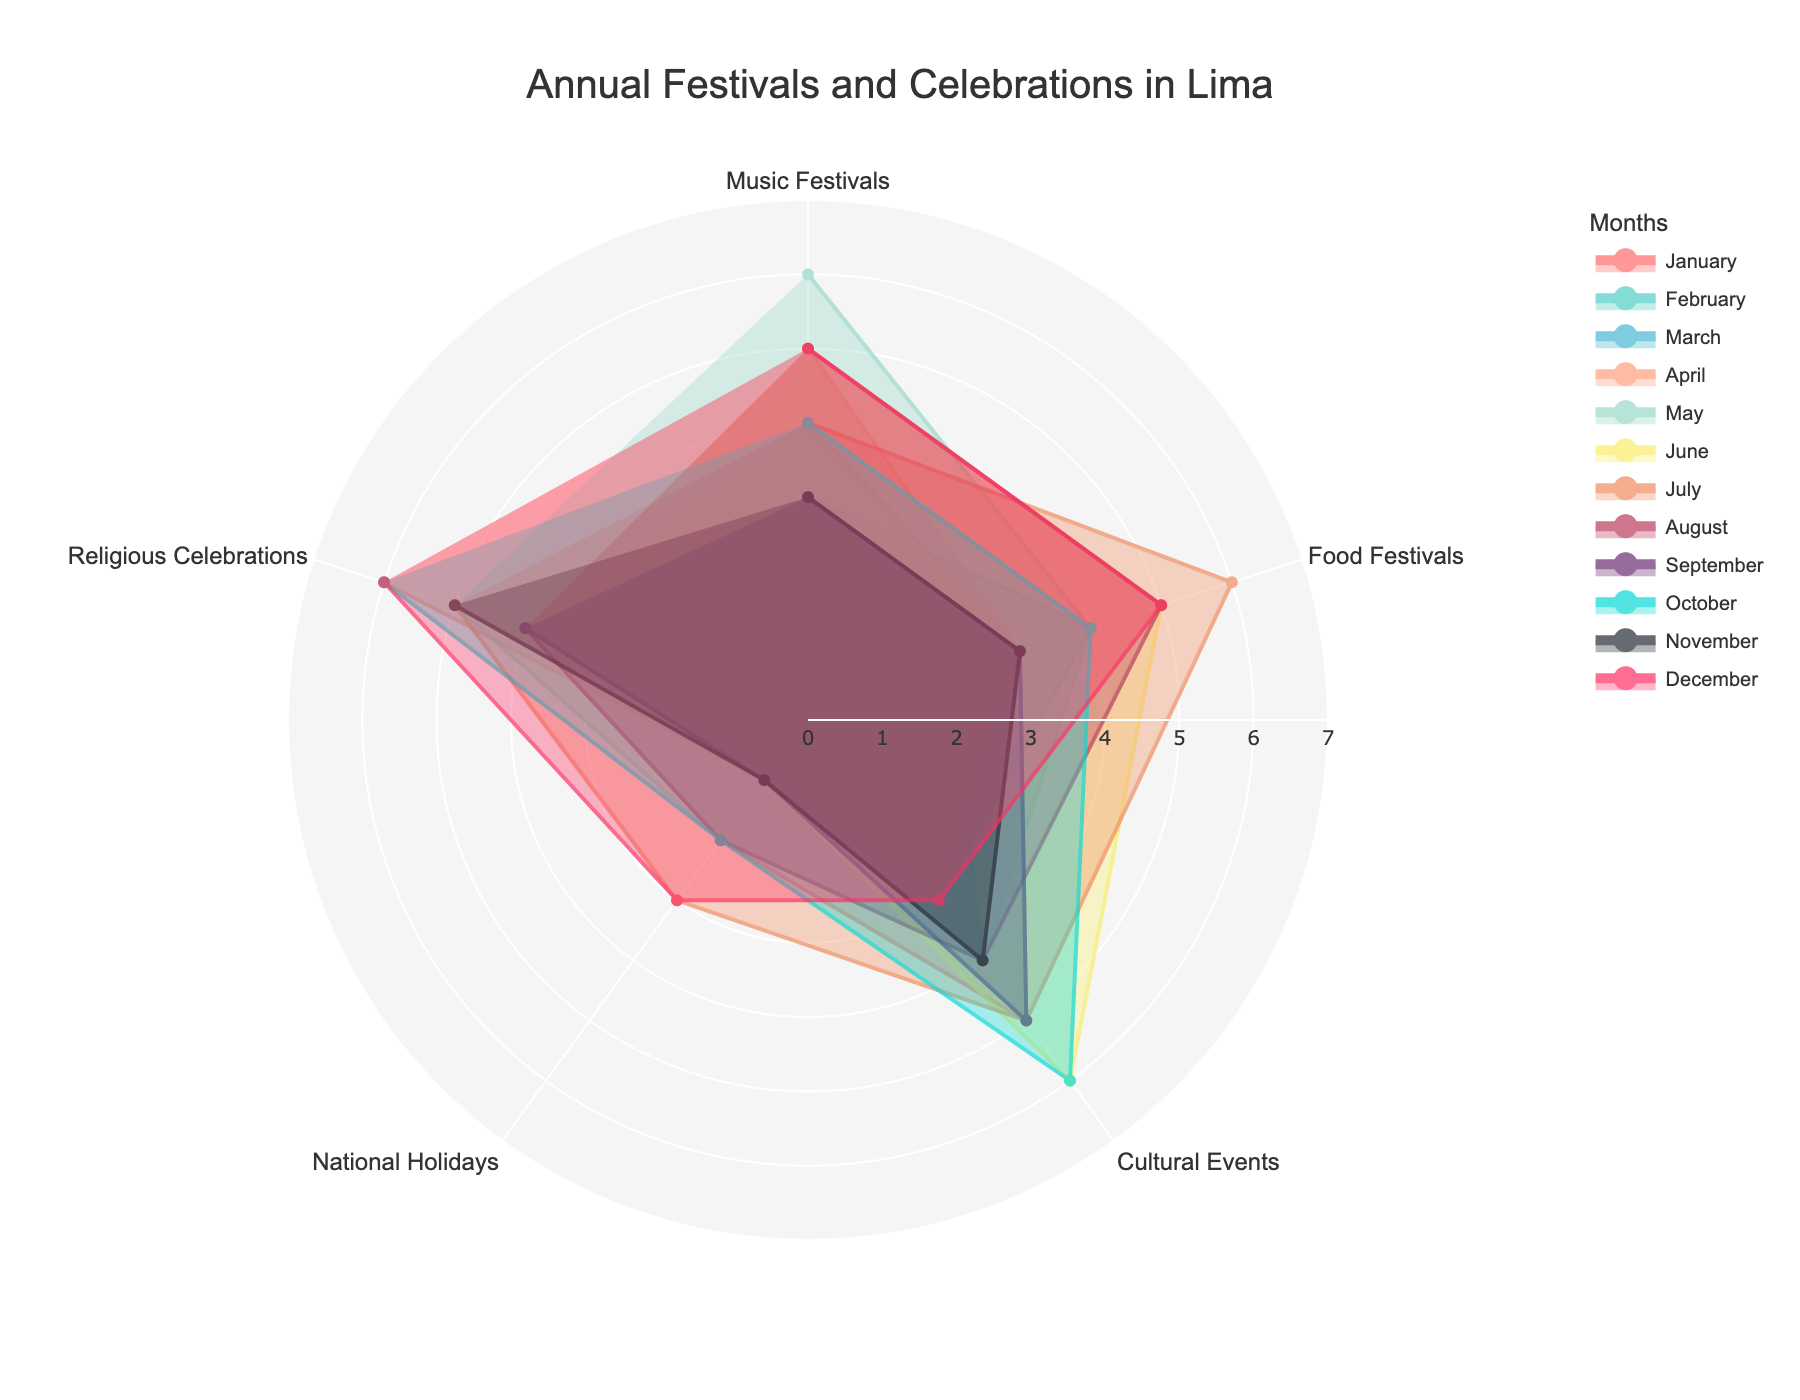What's the title of the figure? The title of the figure is located usually at the top and it gives an overall description of what the radar chart represents. The title helps in understanding the main subject of the chart.
Answer: Annual Festivals and Celebrations in Lima Which month has the highest number of Food Festivals? By examining the radar chart segments specific to Food Festivals, identify the month where the segment extends the furthest. This indicates the highest value.
Answer: July What is the average number of Religious Celebrations from January to December? Sum the values for Religious Celebrations across all months and divide by the number of months (12). (4 + 4 + 5 + 6 + 5 + 4 + 5 + 4 + 4 + 6 + 5 + 6) / 12 = 58 / 12
Answer: 4.83 During which month are Cultural Events most celebrated? Look at the specific segments for Cultural Events and find the month where this segment reaches its maximum value.
Answer: October Which has more National Holidays, April or December? Compare the segments for National Holidays in April and December. Observe which segment extends further on the radar chart.
Answer: December In which month are Music Festivals and Food Festivals equally celebrated? Compare the values for both categories across all months and find where the values match.
Answer: February Find the month with the most total celebrations (sum of all categories). Sum the values of all categories for each month and identify the month with the highest total. For example, for June: 5(Music Festivals) + 5(Food Festivals) + 6(Cultural Events) + 1(National Holidays) + 4(Religious Celebrations) = 21. Calculate for all months and compare.
Answer: June Which month has the most diverse range of festivals (highest total minus lowest total)? Determine the range of festivals by subtracting the minimum value from the maximum value for each month. Identify the month with the largest range difference.
Answer: April (6 - 1 = 5) Is there a month where there are no National Holidays? Check the values for National Holidays in each month, looking for a zero value.
Answer: No 